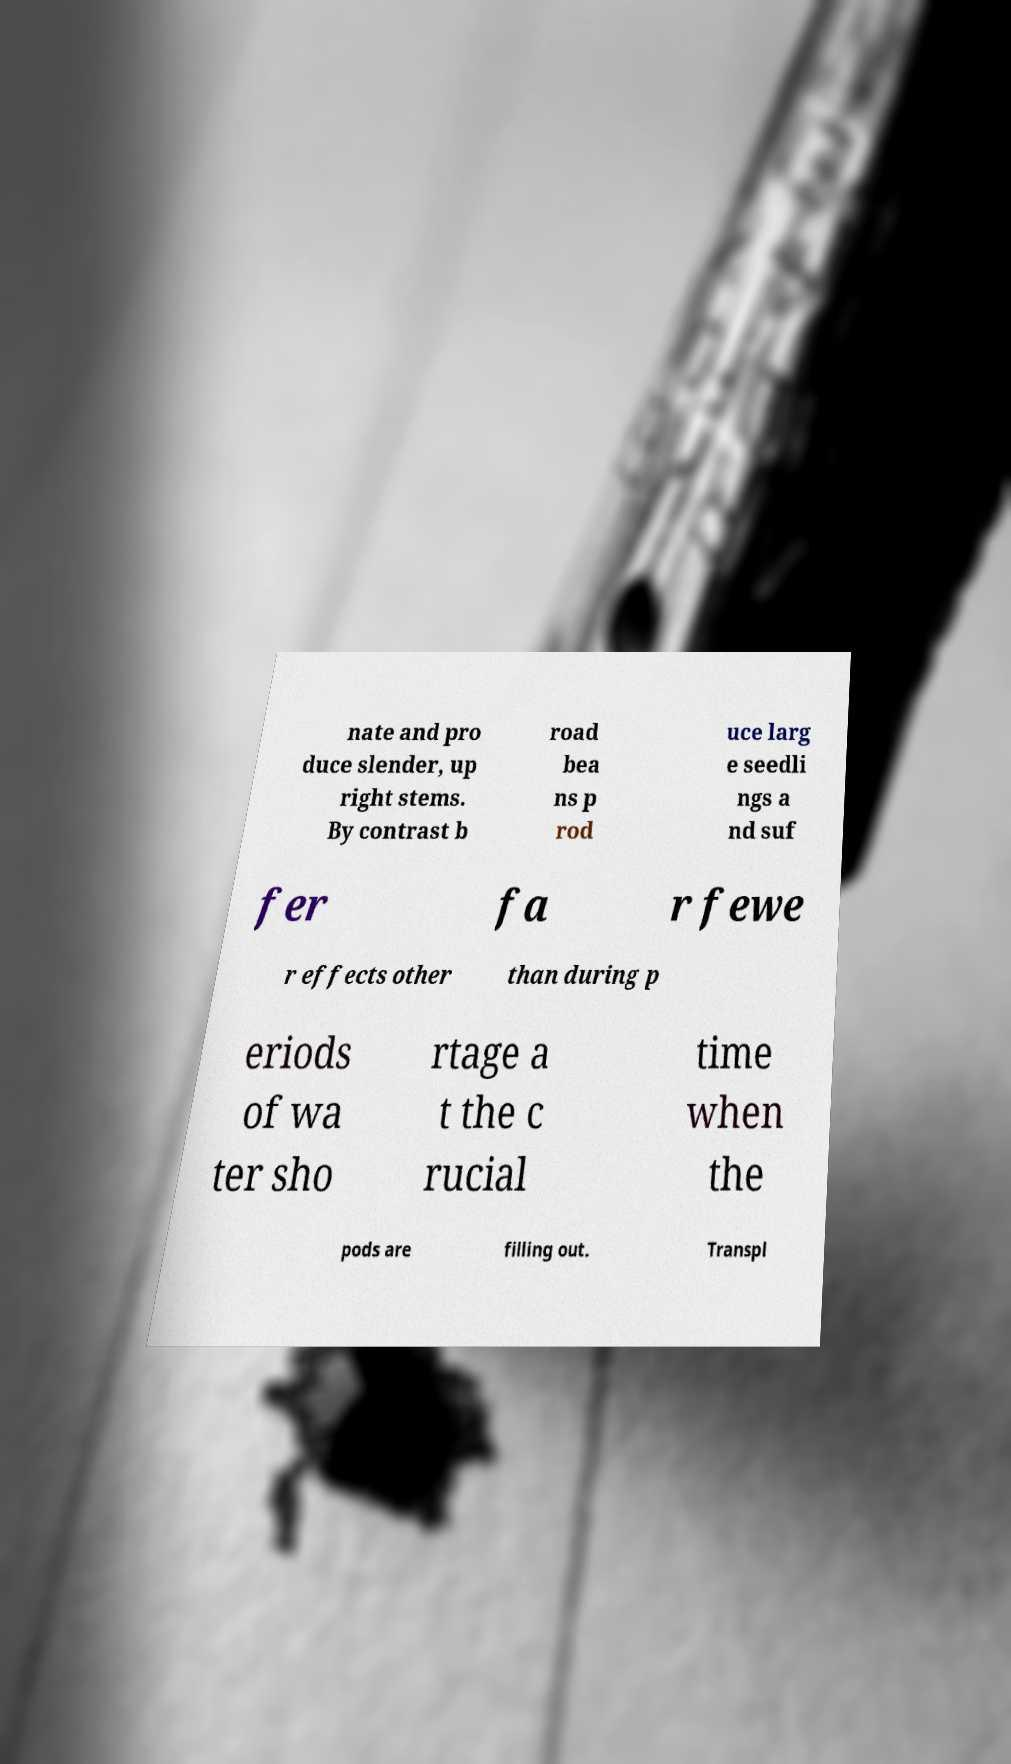What messages or text are displayed in this image? I need them in a readable, typed format. nate and pro duce slender, up right stems. By contrast b road bea ns p rod uce larg e seedli ngs a nd suf fer fa r fewe r effects other than during p eriods of wa ter sho rtage a t the c rucial time when the pods are filling out. Transpl 